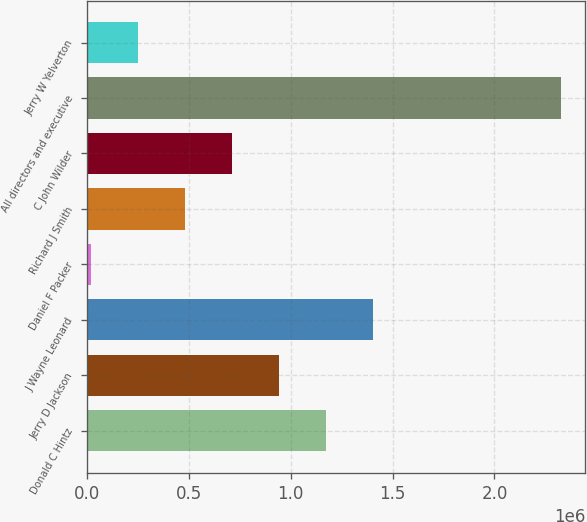<chart> <loc_0><loc_0><loc_500><loc_500><bar_chart><fcel>Donald C Hintz<fcel>Jerry D Jackson<fcel>J Wayne Leonard<fcel>Daniel F Packer<fcel>Richard J Smith<fcel>C John Wilder<fcel>All directors and executive<fcel>Jerry W Yelverton<nl><fcel>1.17577e+06<fcel>945255<fcel>1.40628e+06<fcel>23199<fcel>484227<fcel>714741<fcel>2.32834e+06<fcel>253713<nl></chart> 